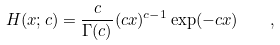Convert formula to latex. <formula><loc_0><loc_0><loc_500><loc_500>H ( x ; c ) = \frac { c } { \Gamma ( c ) } ( c x ) ^ { c - 1 } \exp ( - c x ) \quad ,</formula> 